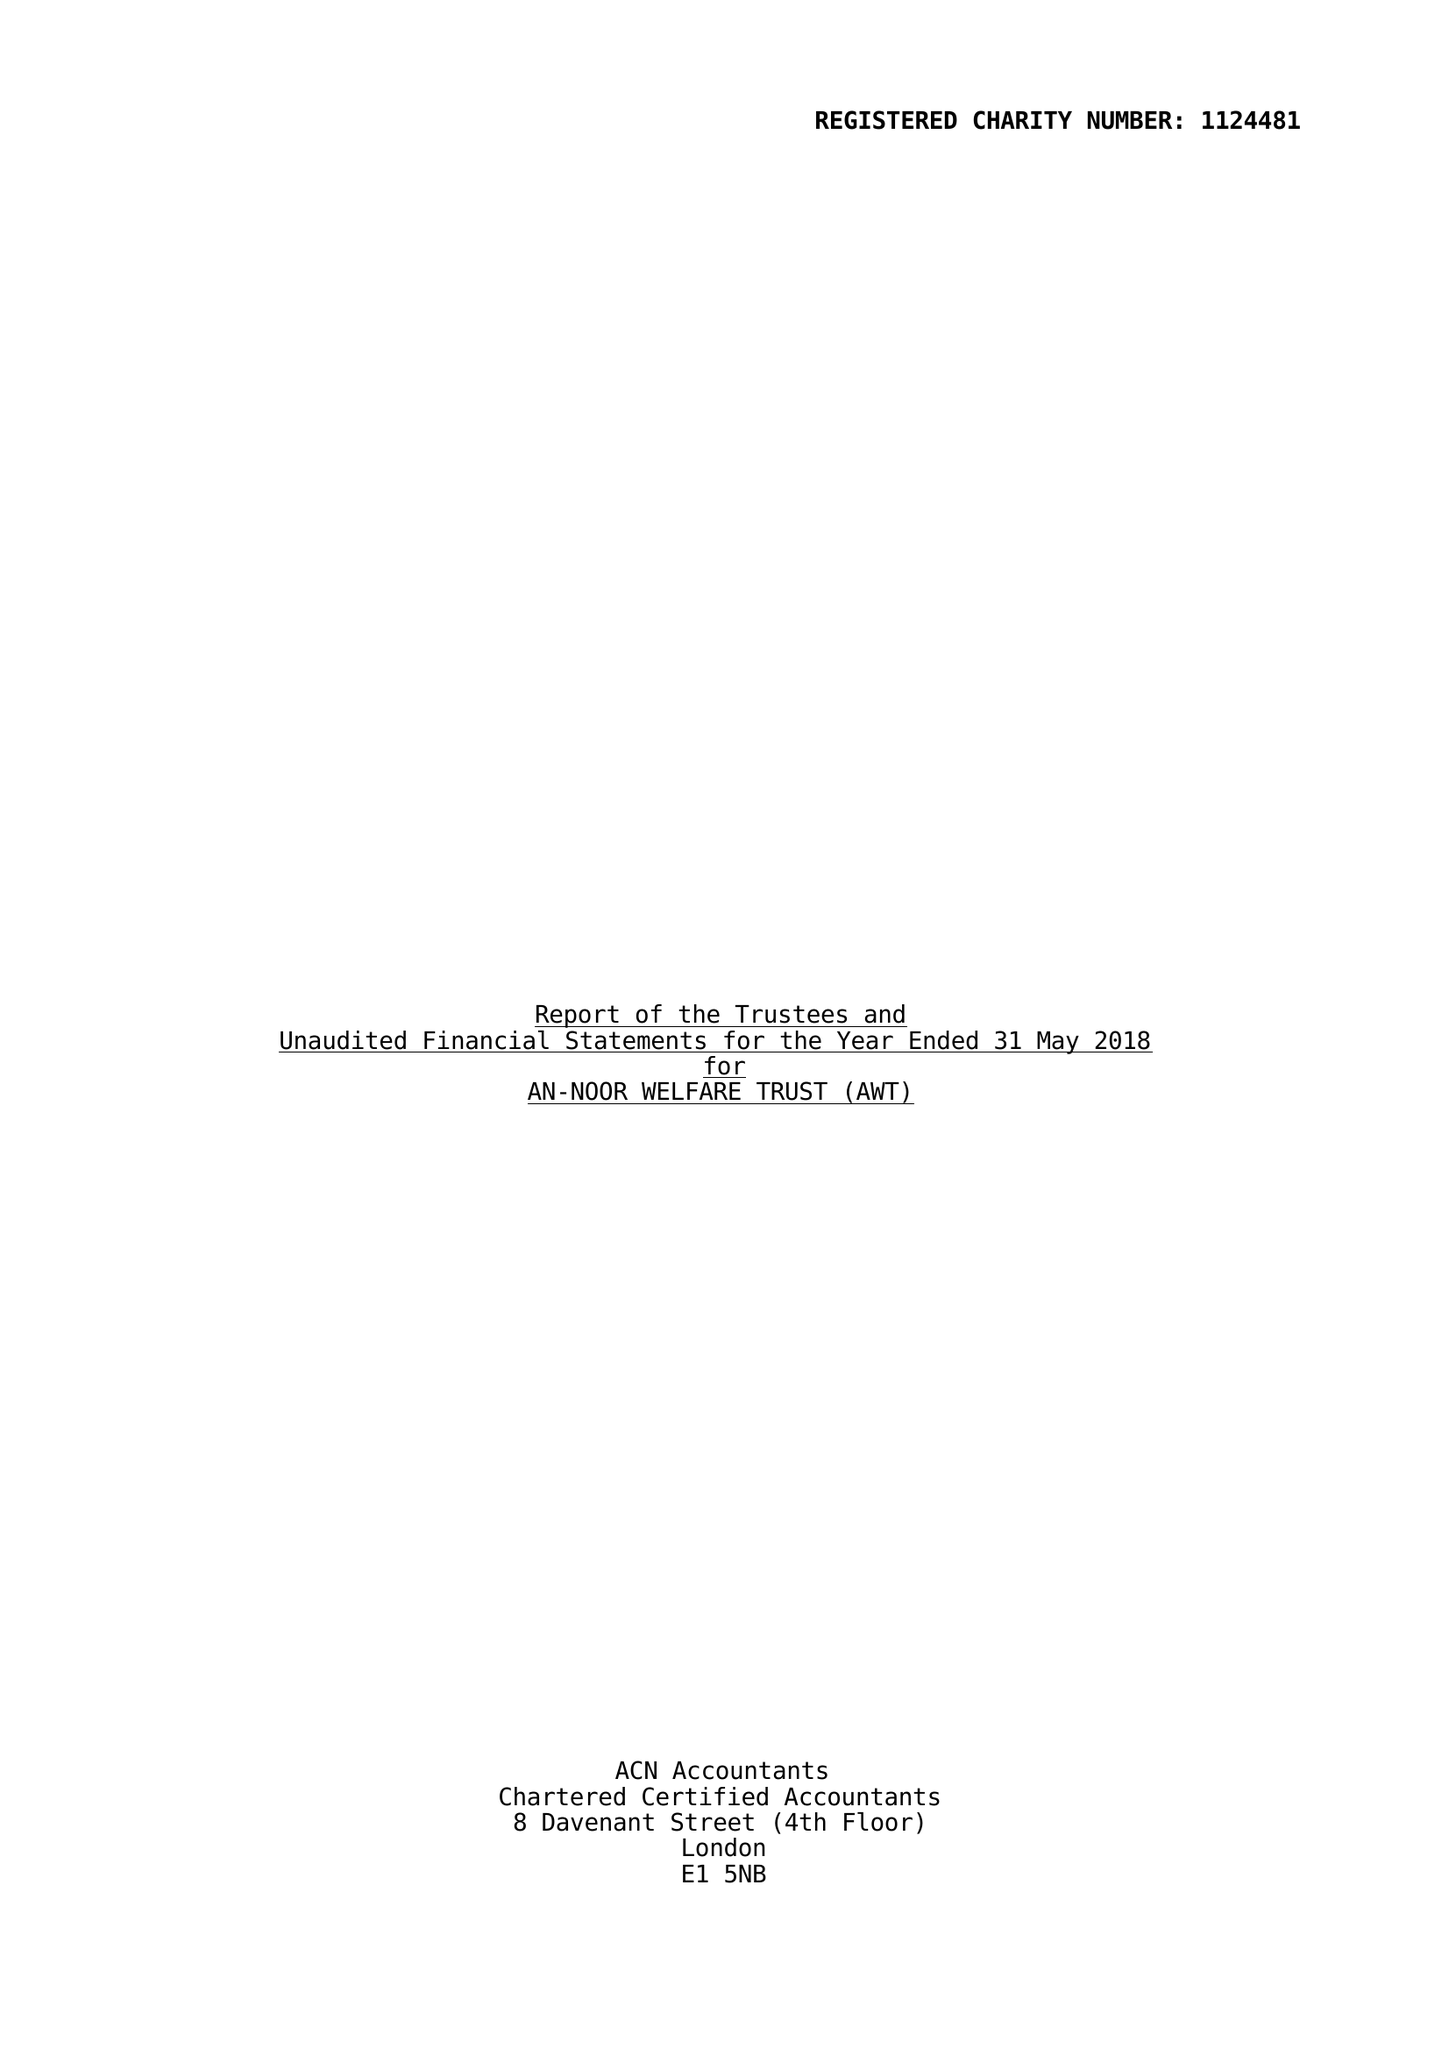What is the value for the address__street_line?
Answer the question using a single word or phrase. CLAYTON ROAD 